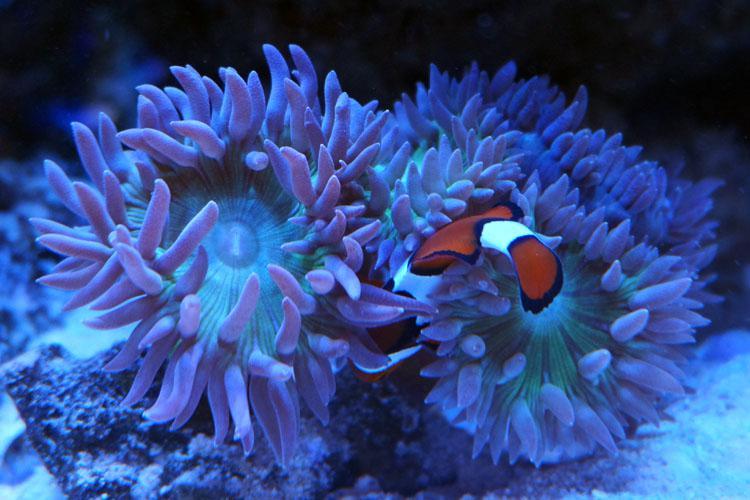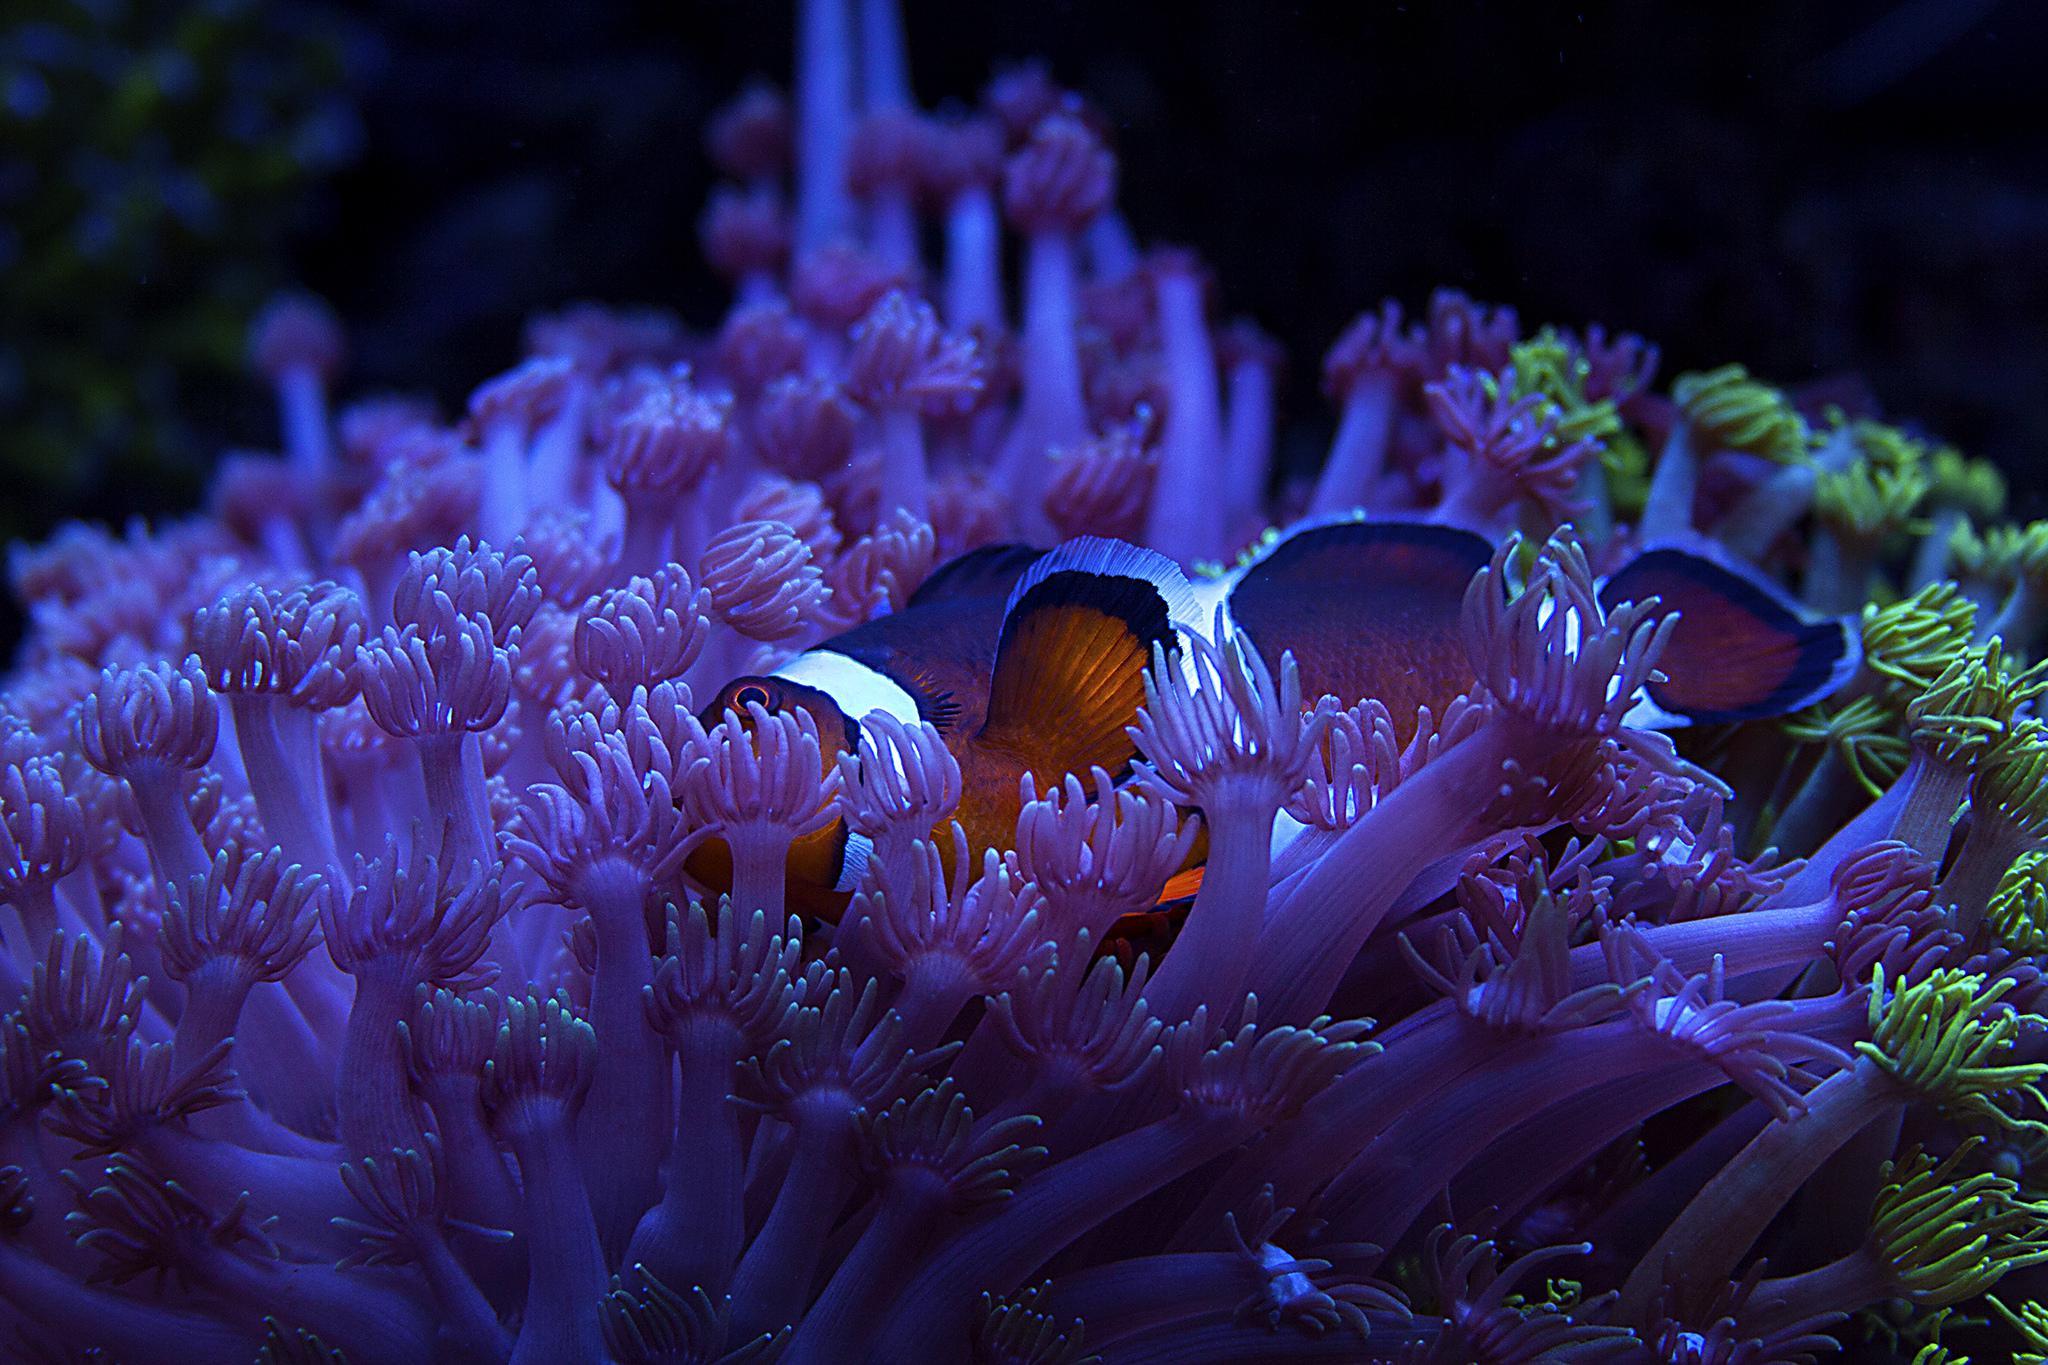The first image is the image on the left, the second image is the image on the right. Examine the images to the left and right. Is the description "In both pictures a clownfish is swimming in a sea anemone." accurate? Answer yes or no. Yes. The first image is the image on the left, the second image is the image on the right. Assess this claim about the two images: "At least one image features a striped fish atop a purplish-blue anemone.". Correct or not? Answer yes or no. Yes. 